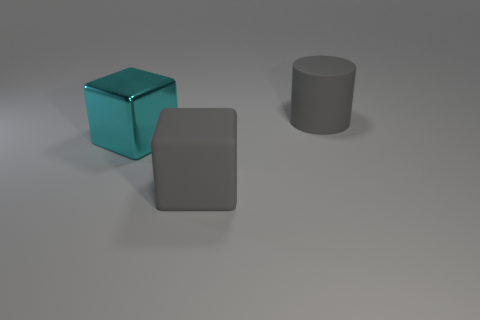Add 1 large gray rubber cylinders. How many objects exist? 4 Subtract all cylinders. How many objects are left? 2 Add 2 large gray things. How many large gray things are left? 4 Add 3 cyan metallic cubes. How many cyan metallic cubes exist? 4 Subtract 0 purple spheres. How many objects are left? 3 Subtract all cyan metallic objects. Subtract all small gray matte cubes. How many objects are left? 2 